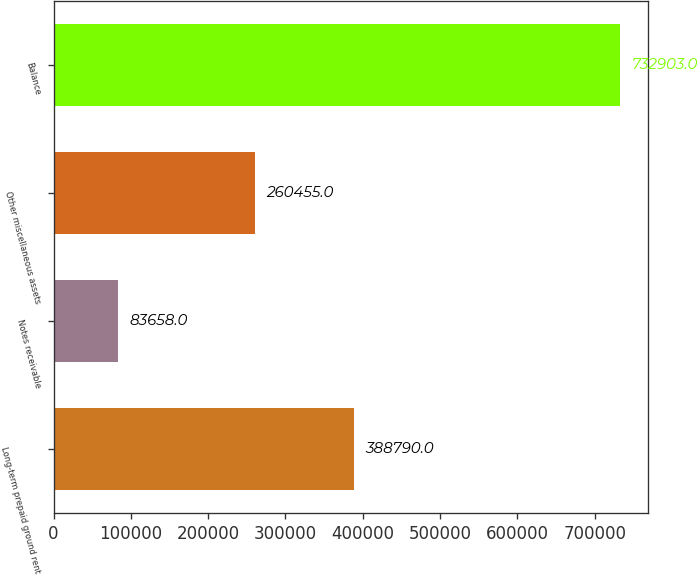Convert chart. <chart><loc_0><loc_0><loc_500><loc_500><bar_chart><fcel>Long-term prepaid ground rent<fcel>Notes receivable<fcel>Other miscellaneous assets<fcel>Balance<nl><fcel>388790<fcel>83658<fcel>260455<fcel>732903<nl></chart> 